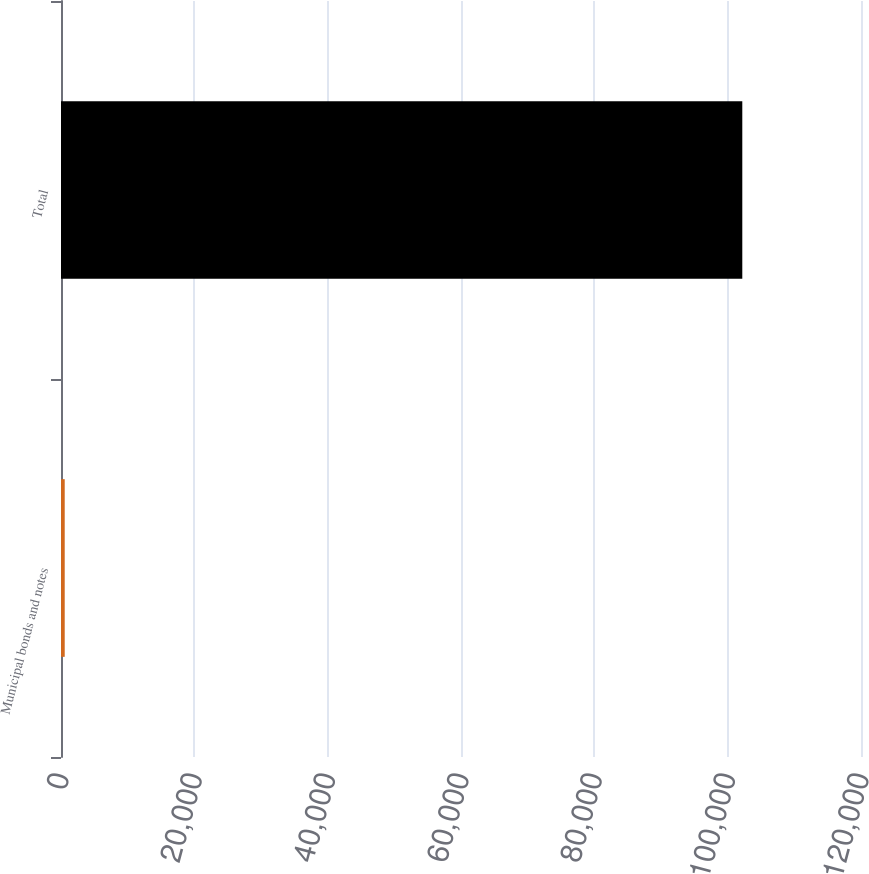<chart> <loc_0><loc_0><loc_500><loc_500><bar_chart><fcel>Municipal bonds and notes<fcel>Total<nl><fcel>558<fcel>102194<nl></chart> 